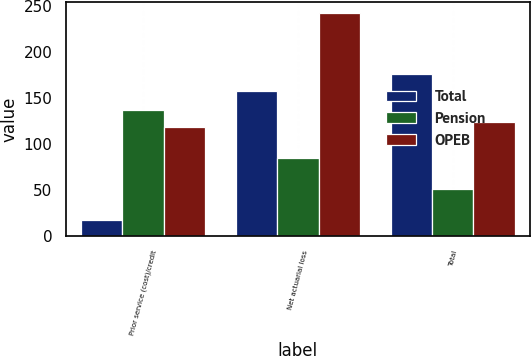Convert chart. <chart><loc_0><loc_0><loc_500><loc_500><stacked_bar_chart><ecel><fcel>Prior service (cost)/credit<fcel>Net actuarial loss<fcel>Total<nl><fcel>Total<fcel>18<fcel>158<fcel>176<nl><fcel>Pension<fcel>137<fcel>85<fcel>52<nl><fcel>OPEB<fcel>119<fcel>243<fcel>124<nl></chart> 